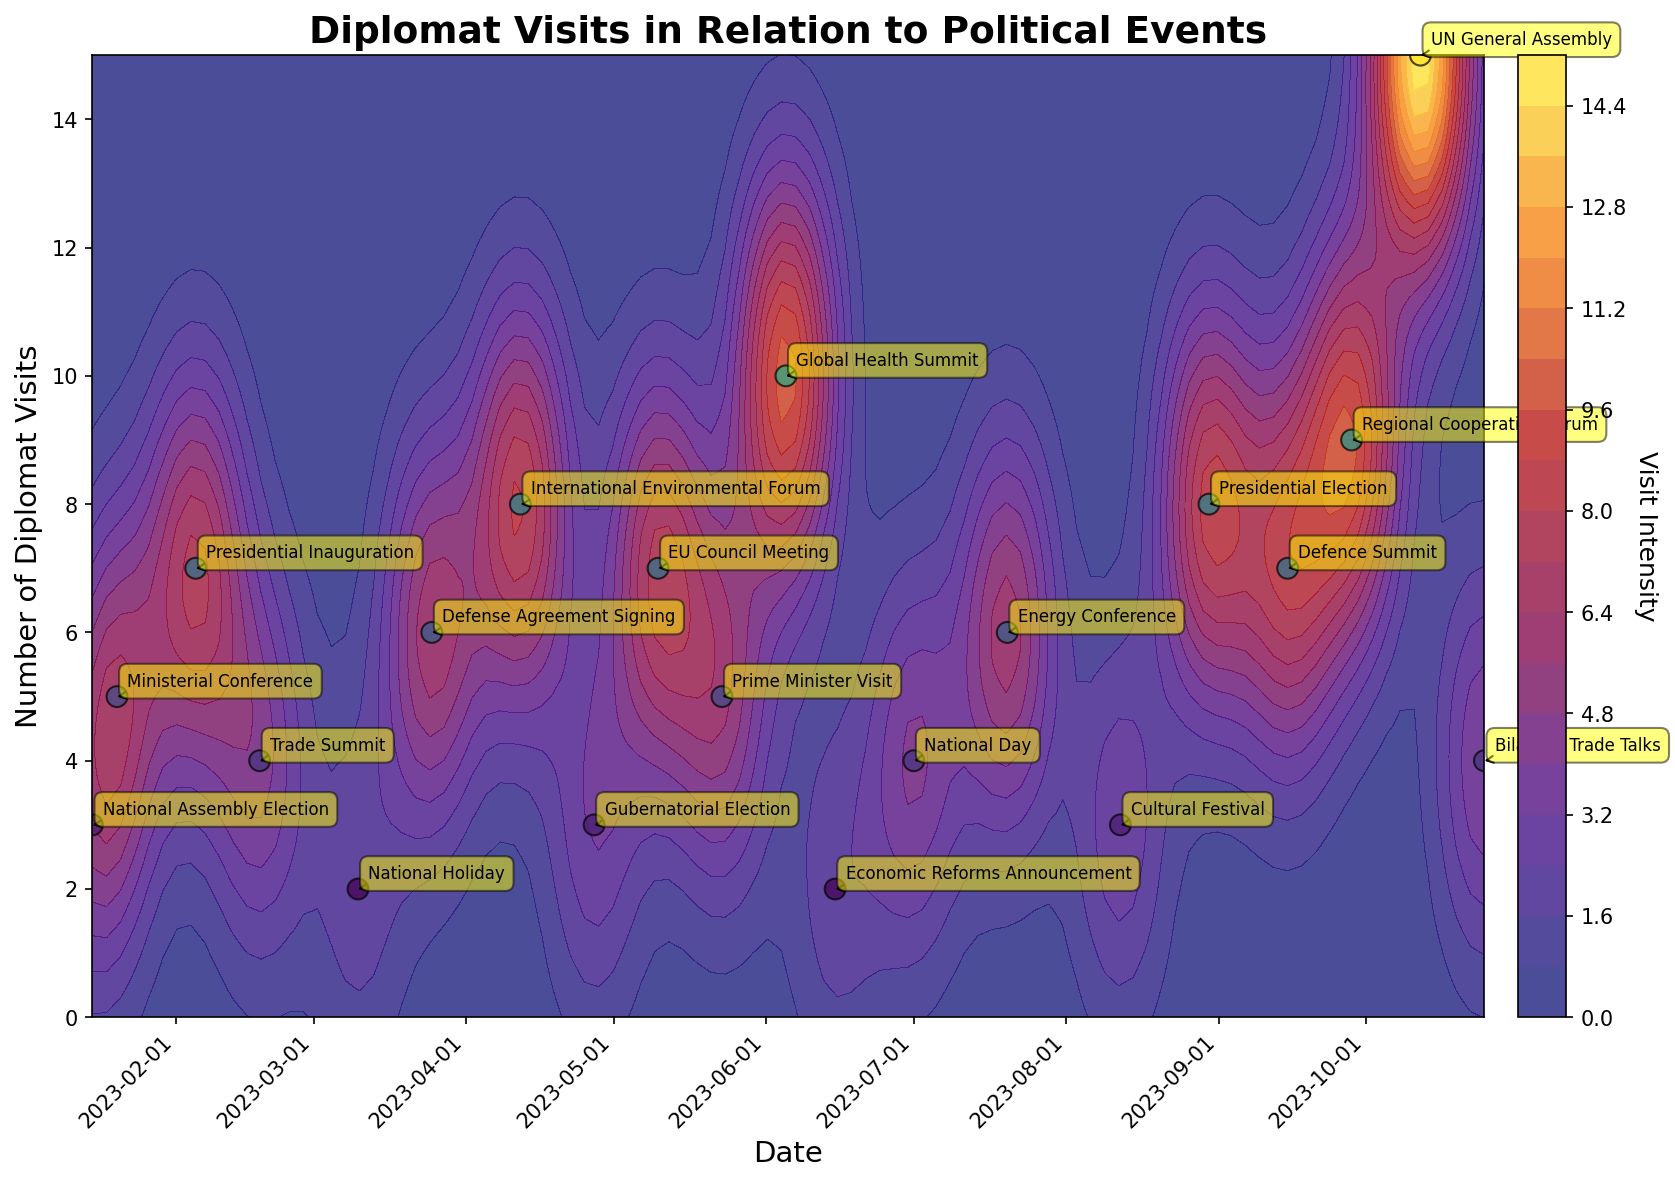What is the title of the plot? The title of the plot is usually visible at the top. In this case, it is "Diplomat Visits in Relation to Political Events," which succinctly describes the focus of the plot and indicates it's a relational analysis between diplomatic visits and political events.
Answer: Diplomat Visits in Relation to Political Events How many major events are annotated on the plot? Each annotation represents an event with the name tagged near a specific data point. By counting all the annotated names, we can determine the number of major events.
Answer: 19 Which event had the highest number of diplomat visits, and how many were there? By observing the y-axis for the highest value and finding the corresponding event label near the highest contour plot density or the highlighted scatter point, we can identify the event. The highest number of diplomat visits appears to be 15, which aligns with the “UN General Assembly” event.
Answer: UN General Assembly, 15 What is the color of the highest visit intensity area on the contour plot? The highest contour intensity is represented by the warmest color in the custom color map, which transitions from deep blue to vibrant yellow. The highest intensity area would thus be yellow.
Answer: Yellow How many events had more than 5 diplomat visits according to the plot? By scanning the scatter points and labels, count the events with values on the y-axis exceeding 5. These typically appear with high contour density. There are 7 such events.
Answer: 7 Which two events had the same number of diplomat visits, and what is that number? To find this, we need to look for overlapping y-axis values among different annotated events. Both "Ministerial Conference" and "Prime Minister Visit" have 5 diplomat visits.
Answer: Ministerial Conference and Prime Minister Visit; 5 During which month did the Defense Agreement Signing event occur, and how many visits did it involve? The x-axis displays the date. Find the label "Defense Agreement Signing," and trace it to the x-axis. This event falls around March and had 6 visits.
Answer: March, 6 Compared to the "National Assembly Election," did the "Gubernatorial Election" have more or fewer diplomat visits? By checking the y-axis values related to these events, we note that the "National Assembly Election" had 3 visits, while the "Gubernatorial Election" also had 3 visits. Therefore, they had an equal number of visits.
Answer: Equal What is the range of visit intensity values depicted on the contour plot? The contour plot’s color bar, often with gradations, indicates the range. It typically goes from the lowest to the highest values depicted. Here, it ranges from a minimum (likely the darkest color) to a maximum (brightest yellow).
Answer: 0 to 15 Which month appeared to be the least popular for diplomat visits based on the contour density? By observing the contour density and scatter points throughout months, the areas with sparse or lower intensity give us insight. Around January appears to have lower intensity, indicating it’s less popular for visits.
Answer: January 